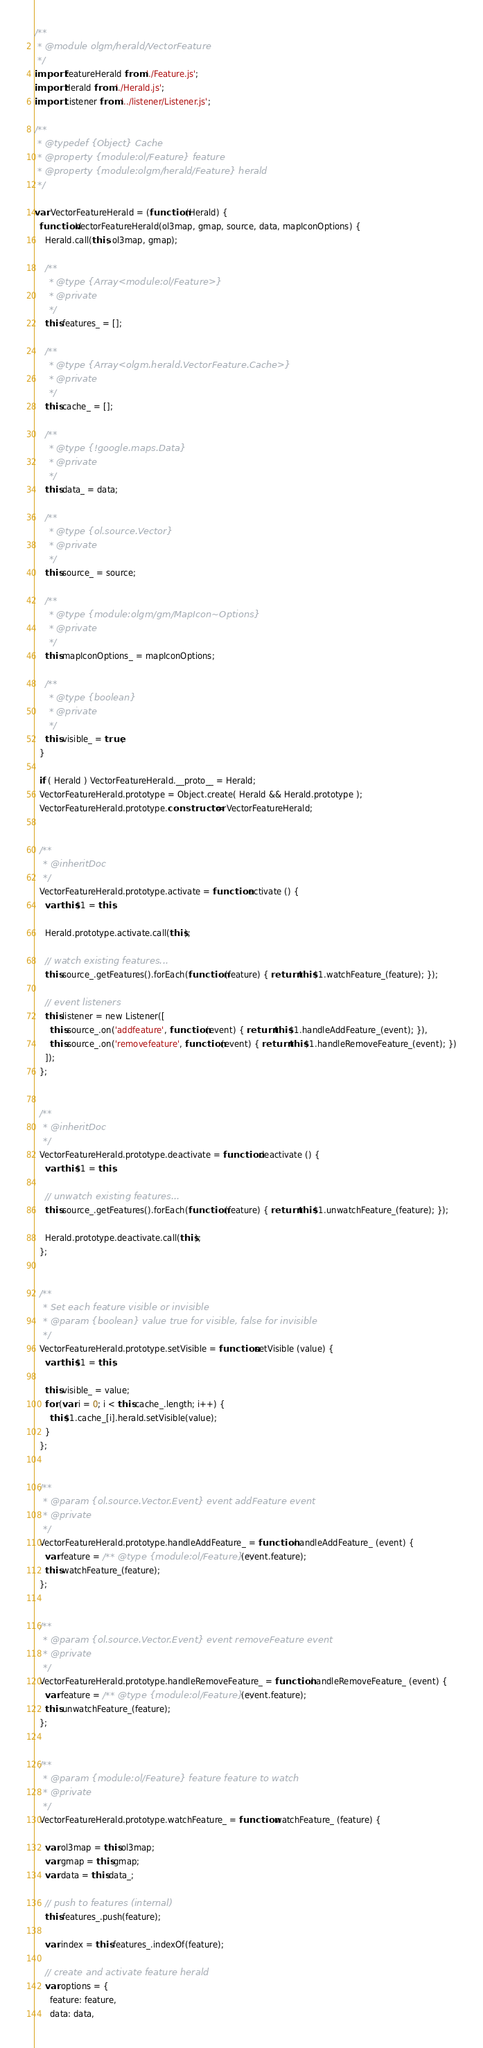<code> <loc_0><loc_0><loc_500><loc_500><_JavaScript_>/**
 * @module olgm/herald/VectorFeature
 */
import FeatureHerald from './Feature.js';
import Herald from './Herald.js';
import Listener from '../listener/Listener.js';

/**
 * @typedef {Object} Cache
 * @property {module:ol/Feature} feature
 * @property {module:olgm/herald/Feature} herald
 */

var VectorFeatureHerald = (function (Herald) {
  function VectorFeatureHerald(ol3map, gmap, source, data, mapIconOptions) {
    Herald.call(this, ol3map, gmap);

    /**
     * @type {Array<module:ol/Feature>}
     * @private
     */
    this.features_ = [];

    /**
     * @type {Array<olgm.herald.VectorFeature.Cache>}
     * @private
     */
    this.cache_ = [];

    /**
     * @type {!google.maps.Data}
     * @private
     */
    this.data_ = data;

    /**
     * @type {ol.source.Vector}
     * @private
     */
    this.source_ = source;

    /**
     * @type {module:olgm/gm/MapIcon~Options}
     * @private
     */
    this.mapIconOptions_ = mapIconOptions;

    /**
     * @type {boolean}
     * @private
     */
    this.visible_ = true;
  }

  if ( Herald ) VectorFeatureHerald.__proto__ = Herald;
  VectorFeatureHerald.prototype = Object.create( Herald && Herald.prototype );
  VectorFeatureHerald.prototype.constructor = VectorFeatureHerald;


  /**
   * @inheritDoc
   */
  VectorFeatureHerald.prototype.activate = function activate () {
    var this$1 = this;

    Herald.prototype.activate.call(this);

    // watch existing features...
    this.source_.getFeatures().forEach(function (feature) { return this$1.watchFeature_(feature); });

    // event listeners
    this.listener = new Listener([
      this.source_.on('addfeature', function (event) { return this$1.handleAddFeature_(event); }),
      this.source_.on('removefeature', function (event) { return this$1.handleRemoveFeature_(event); })
    ]);
  };


  /**
   * @inheritDoc
   */
  VectorFeatureHerald.prototype.deactivate = function deactivate () {
    var this$1 = this;

    // unwatch existing features...
    this.source_.getFeatures().forEach(function (feature) { return this$1.unwatchFeature_(feature); });

    Herald.prototype.deactivate.call(this);
  };


  /**
   * Set each feature visible or invisible
   * @param {boolean} value true for visible, false for invisible
   */
  VectorFeatureHerald.prototype.setVisible = function setVisible (value) {
    var this$1 = this;

    this.visible_ = value;
    for (var i = 0; i < this.cache_.length; i++) {
      this$1.cache_[i].herald.setVisible(value);
    }
  };


  /**
   * @param {ol.source.Vector.Event} event addFeature event
   * @private
   */
  VectorFeatureHerald.prototype.handleAddFeature_ = function handleAddFeature_ (event) {
    var feature = /** @type {module:ol/Feature} */ (event.feature);
    this.watchFeature_(feature);
  };


  /**
   * @param {ol.source.Vector.Event} event removeFeature event
   * @private
   */
  VectorFeatureHerald.prototype.handleRemoveFeature_ = function handleRemoveFeature_ (event) {
    var feature = /** @type {module:ol/Feature} */ (event.feature);
    this.unwatchFeature_(feature);
  };


  /**
   * @param {module:ol/Feature} feature feature to watch
   * @private
   */
  VectorFeatureHerald.prototype.watchFeature_ = function watchFeature_ (feature) {

    var ol3map = this.ol3map;
    var gmap = this.gmap;
    var data = this.data_;

    // push to features (internal)
    this.features_.push(feature);

    var index = this.features_.indexOf(feature);

    // create and activate feature herald
    var options = {
      feature: feature,
      data: data,</code> 